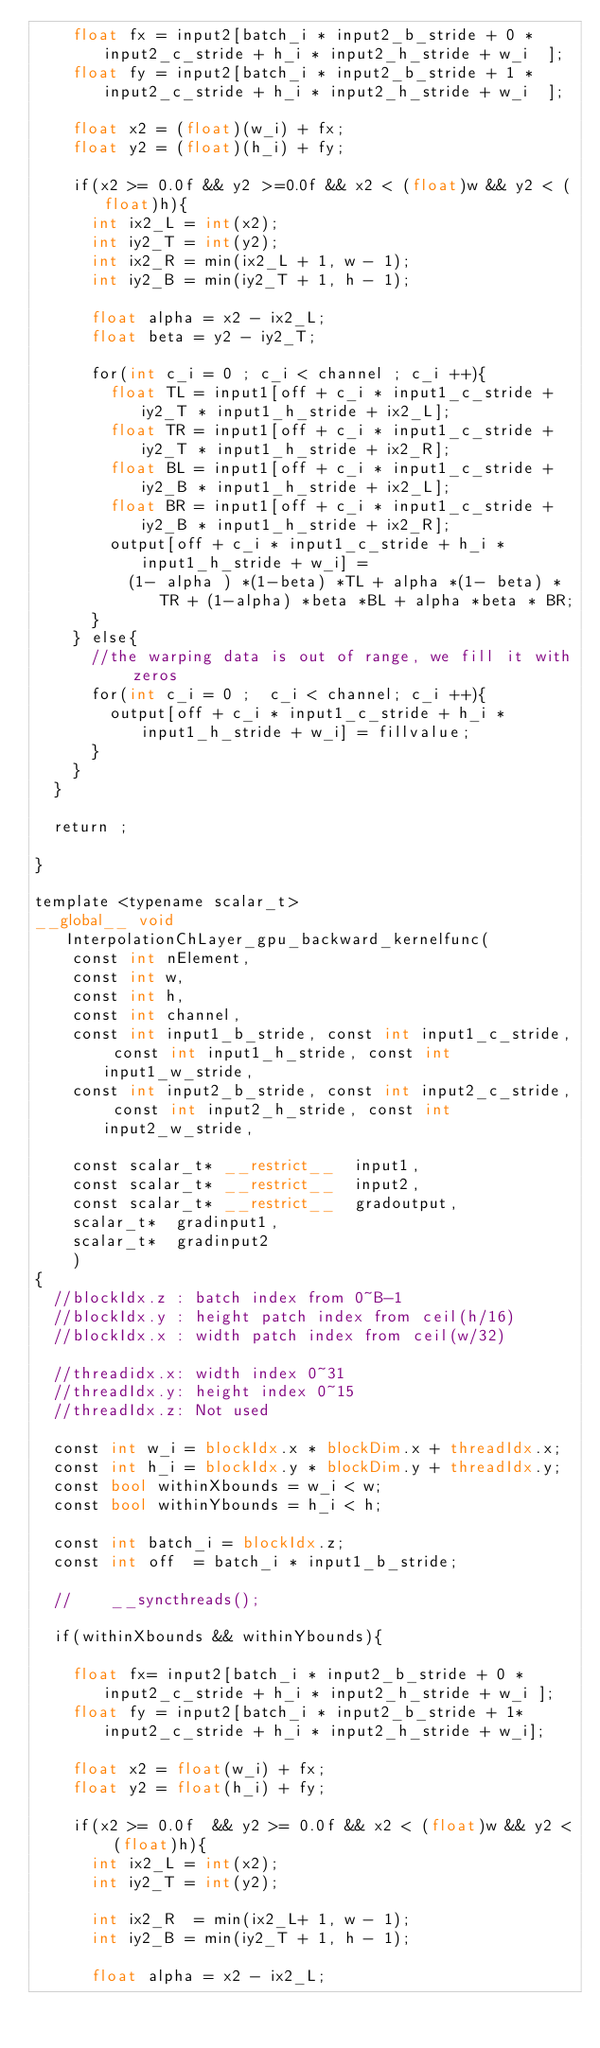Convert code to text. <code><loc_0><loc_0><loc_500><loc_500><_Cuda_>		float fx = input2[batch_i * input2_b_stride + 0 * input2_c_stride + h_i * input2_h_stride + w_i  ];
		float fy = input2[batch_i * input2_b_stride + 1 * input2_c_stride + h_i * input2_h_stride + w_i  ];

		float x2 = (float)(w_i) + fx;
		float y2 = (float)(h_i) + fy;

		if(x2 >= 0.0f && y2 >=0.0f && x2 < (float)w && y2 < (float)h){
			int ix2_L = int(x2);
			int iy2_T = int(y2);
			int ix2_R = min(ix2_L + 1, w - 1);
			int iy2_B = min(iy2_T + 1, h - 1);

			float alpha = x2 - ix2_L;
			float beta = y2 - iy2_T;

			for(int c_i = 0 ; c_i < channel ; c_i ++){
				float TL = input1[off + c_i * input1_c_stride + iy2_T * input1_h_stride + ix2_L];
				float TR = input1[off + c_i * input1_c_stride + iy2_T * input1_h_stride + ix2_R];
				float BL = input1[off + c_i * input1_c_stride + iy2_B * input1_h_stride + ix2_L];
				float BR = input1[off + c_i * input1_c_stride + iy2_B * input1_h_stride + ix2_R];
				output[off + c_i * input1_c_stride + h_i * input1_h_stride + w_i] =
					(1- alpha ) *(1-beta) *TL + alpha *(1- beta) * TR + (1-alpha) *beta *BL + alpha *beta * BR;
			}
		} else{
			//the warping data is out of range, we fill it with zeros
			for(int c_i = 0 ;  c_i < channel; c_i ++){
				output[off + c_i * input1_c_stride + h_i * input1_h_stride + w_i] = fillvalue;
			}
		}
	}

	return ;

}

template <typename scalar_t>
__global__ void InterpolationChLayer_gpu_backward_kernelfunc(
		const int nElement,
		const int w,
		const int h,
		const int channel,
		const int input1_b_stride, const int input1_c_stride, const int input1_h_stride, const int input1_w_stride,
		const int input2_b_stride, const int input2_c_stride, const int input2_h_stride, const int input2_w_stride,

		const scalar_t* __restrict__  input1,
		const scalar_t* __restrict__  input2,
		const scalar_t* __restrict__  gradoutput,
		scalar_t*  gradinput1,
		scalar_t*  gradinput2
		)
{
	//blockIdx.z : batch index from 0~B-1
	//blockIdx.y : height patch index from ceil(h/16)
	//blockIdx.x : width patch index from ceil(w/32)

	//threadidx.x: width index 0~31
	//threadIdx.y: height index 0~15
	//threadIdx.z: Not used

	const int w_i = blockIdx.x * blockDim.x + threadIdx.x;
	const int h_i = blockIdx.y * blockDim.y + threadIdx.y;
	const bool withinXbounds = w_i < w;
	const bool withinYbounds = h_i < h;

	const int batch_i = blockIdx.z;
	const int off  = batch_i * input1_b_stride;

	//    __syncthreads();

	if(withinXbounds && withinYbounds){

		float fx= input2[batch_i * input2_b_stride + 0 * input2_c_stride + h_i * input2_h_stride + w_i ];
		float fy = input2[batch_i * input2_b_stride + 1* input2_c_stride + h_i * input2_h_stride + w_i];

		float x2 = float(w_i) + fx;
		float y2 = float(h_i) + fy;

		if(x2 >= 0.0f  && y2 >= 0.0f && x2 < (float)w && y2 < (float)h){
			int ix2_L = int(x2);
			int iy2_T = int(y2);

			int ix2_R  = min(ix2_L+ 1, w - 1);
			int iy2_B = min(iy2_T + 1, h - 1);

			float alpha = x2 - ix2_L;</code> 